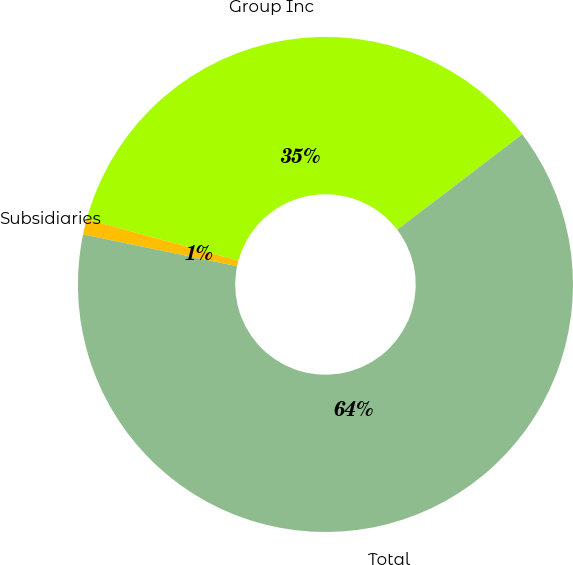Convert chart to OTSL. <chart><loc_0><loc_0><loc_500><loc_500><pie_chart><fcel>Group Inc<fcel>Subsidiaries<fcel>Total<nl><fcel>35.38%<fcel>1.0%<fcel>63.61%<nl></chart> 